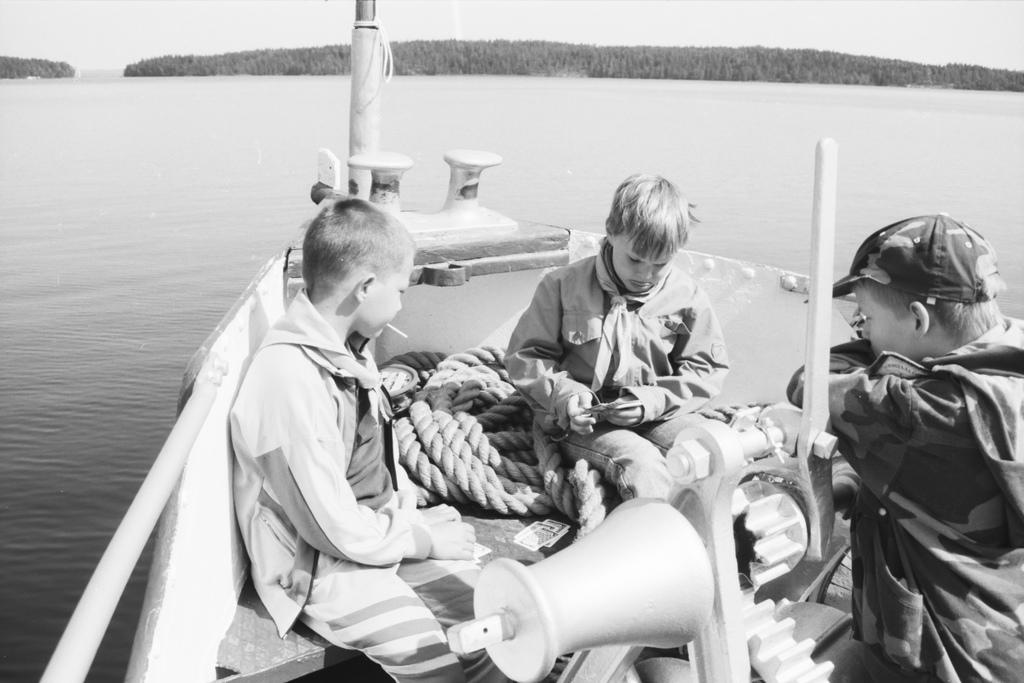What is the main subject of the image? The main subject of the image is water. What is located in the water? There is a boat in the water. What else can be seen in the image? There is a rope visible in the image. Who is present in the image? There are children in the image. What is the color scheme of the image? The image is black and white in color. Can you see a rat playing with the children in the image? There is no rat present in the image; it only features children near the water. What type of wind can be seen blowing the children's hair in the image? The image is black and white, so it is not possible to determine the presence or type of wind in the image. 